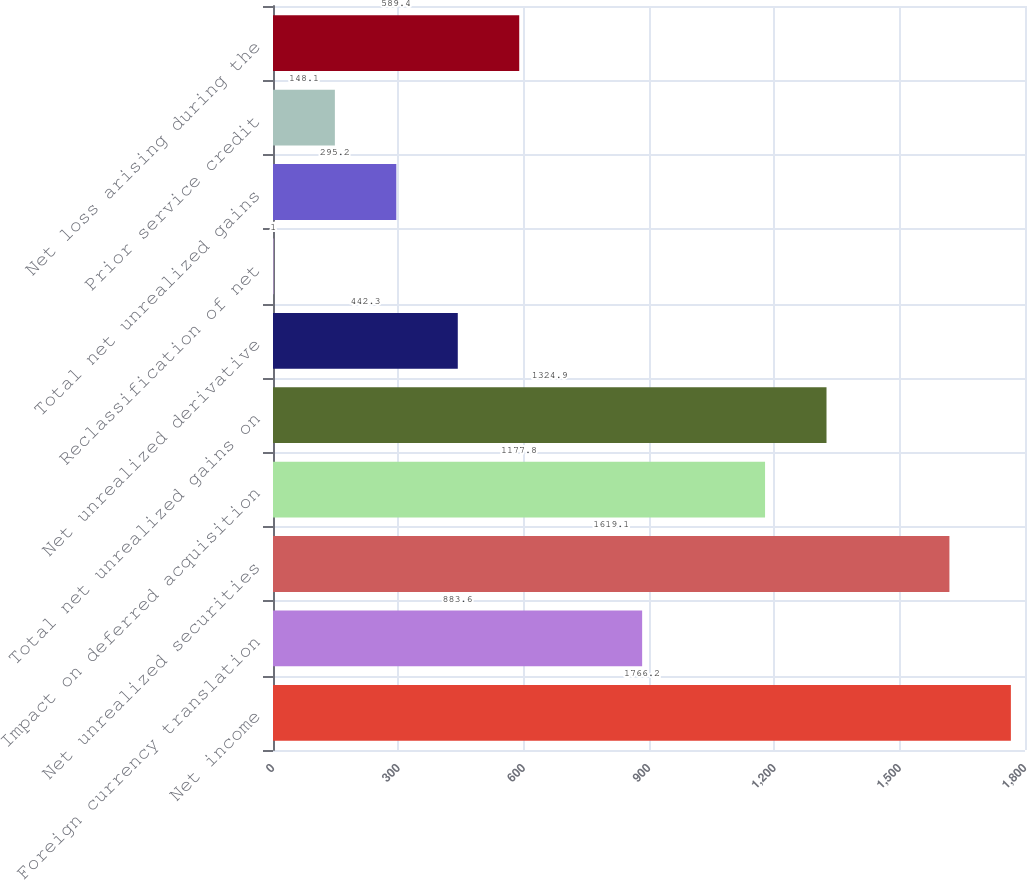Convert chart to OTSL. <chart><loc_0><loc_0><loc_500><loc_500><bar_chart><fcel>Net income<fcel>Foreign currency translation<fcel>Net unrealized securities<fcel>Impact on deferred acquisition<fcel>Total net unrealized gains on<fcel>Net unrealized derivative<fcel>Reclassification of net<fcel>Total net unrealized gains<fcel>Prior service credit<fcel>Net loss arising during the<nl><fcel>1766.2<fcel>883.6<fcel>1619.1<fcel>1177.8<fcel>1324.9<fcel>442.3<fcel>1<fcel>295.2<fcel>148.1<fcel>589.4<nl></chart> 